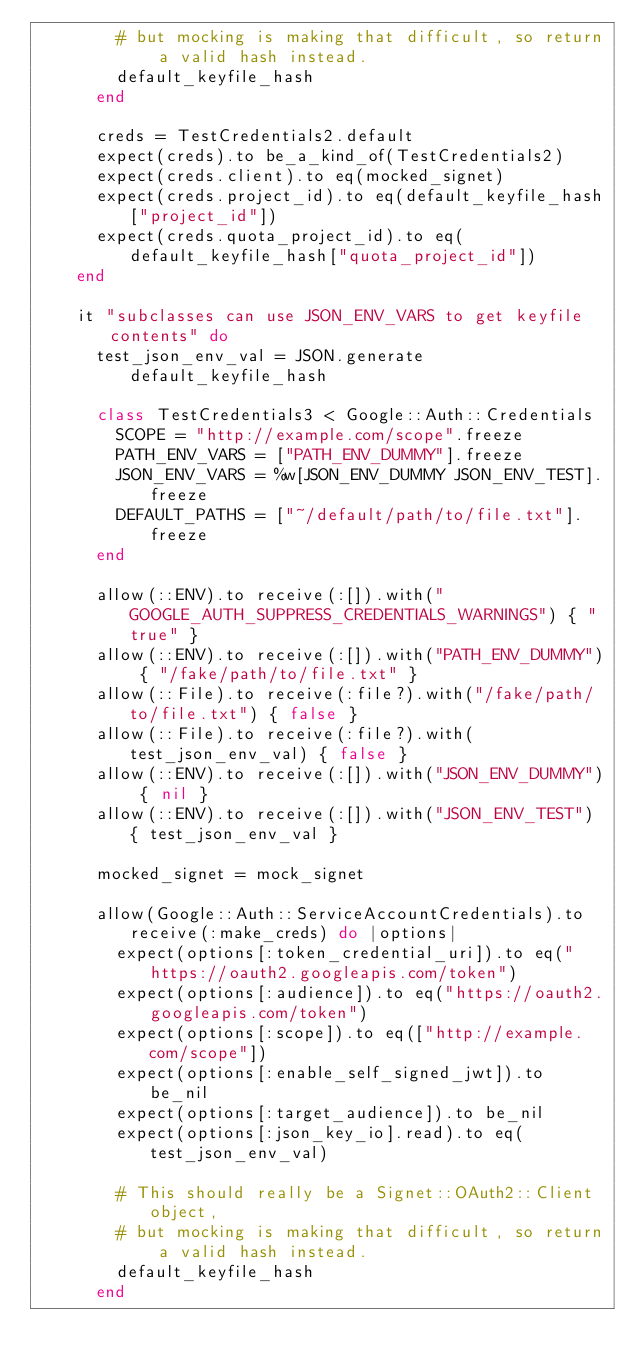Convert code to text. <code><loc_0><loc_0><loc_500><loc_500><_Ruby_>        # but mocking is making that difficult, so return a valid hash instead.
        default_keyfile_hash
      end

      creds = TestCredentials2.default
      expect(creds).to be_a_kind_of(TestCredentials2)
      expect(creds.client).to eq(mocked_signet)
      expect(creds.project_id).to eq(default_keyfile_hash["project_id"])
      expect(creds.quota_project_id).to eq(default_keyfile_hash["quota_project_id"])
    end

    it "subclasses can use JSON_ENV_VARS to get keyfile contents" do
      test_json_env_val = JSON.generate default_keyfile_hash

      class TestCredentials3 < Google::Auth::Credentials
        SCOPE = "http://example.com/scope".freeze
        PATH_ENV_VARS = ["PATH_ENV_DUMMY"].freeze
        JSON_ENV_VARS = %w[JSON_ENV_DUMMY JSON_ENV_TEST].freeze
        DEFAULT_PATHS = ["~/default/path/to/file.txt"].freeze
      end

      allow(::ENV).to receive(:[]).with("GOOGLE_AUTH_SUPPRESS_CREDENTIALS_WARNINGS") { "true" }
      allow(::ENV).to receive(:[]).with("PATH_ENV_DUMMY") { "/fake/path/to/file.txt" }
      allow(::File).to receive(:file?).with("/fake/path/to/file.txt") { false }
      allow(::File).to receive(:file?).with(test_json_env_val) { false }
      allow(::ENV).to receive(:[]).with("JSON_ENV_DUMMY") { nil }
      allow(::ENV).to receive(:[]).with("JSON_ENV_TEST") { test_json_env_val }

      mocked_signet = mock_signet

      allow(Google::Auth::ServiceAccountCredentials).to receive(:make_creds) do |options|
        expect(options[:token_credential_uri]).to eq("https://oauth2.googleapis.com/token")
        expect(options[:audience]).to eq("https://oauth2.googleapis.com/token")
        expect(options[:scope]).to eq(["http://example.com/scope"])
        expect(options[:enable_self_signed_jwt]).to be_nil
        expect(options[:target_audience]).to be_nil
        expect(options[:json_key_io].read).to eq(test_json_env_val)

        # This should really be a Signet::OAuth2::Client object,
        # but mocking is making that difficult, so return a valid hash instead.
        default_keyfile_hash
      end
</code> 